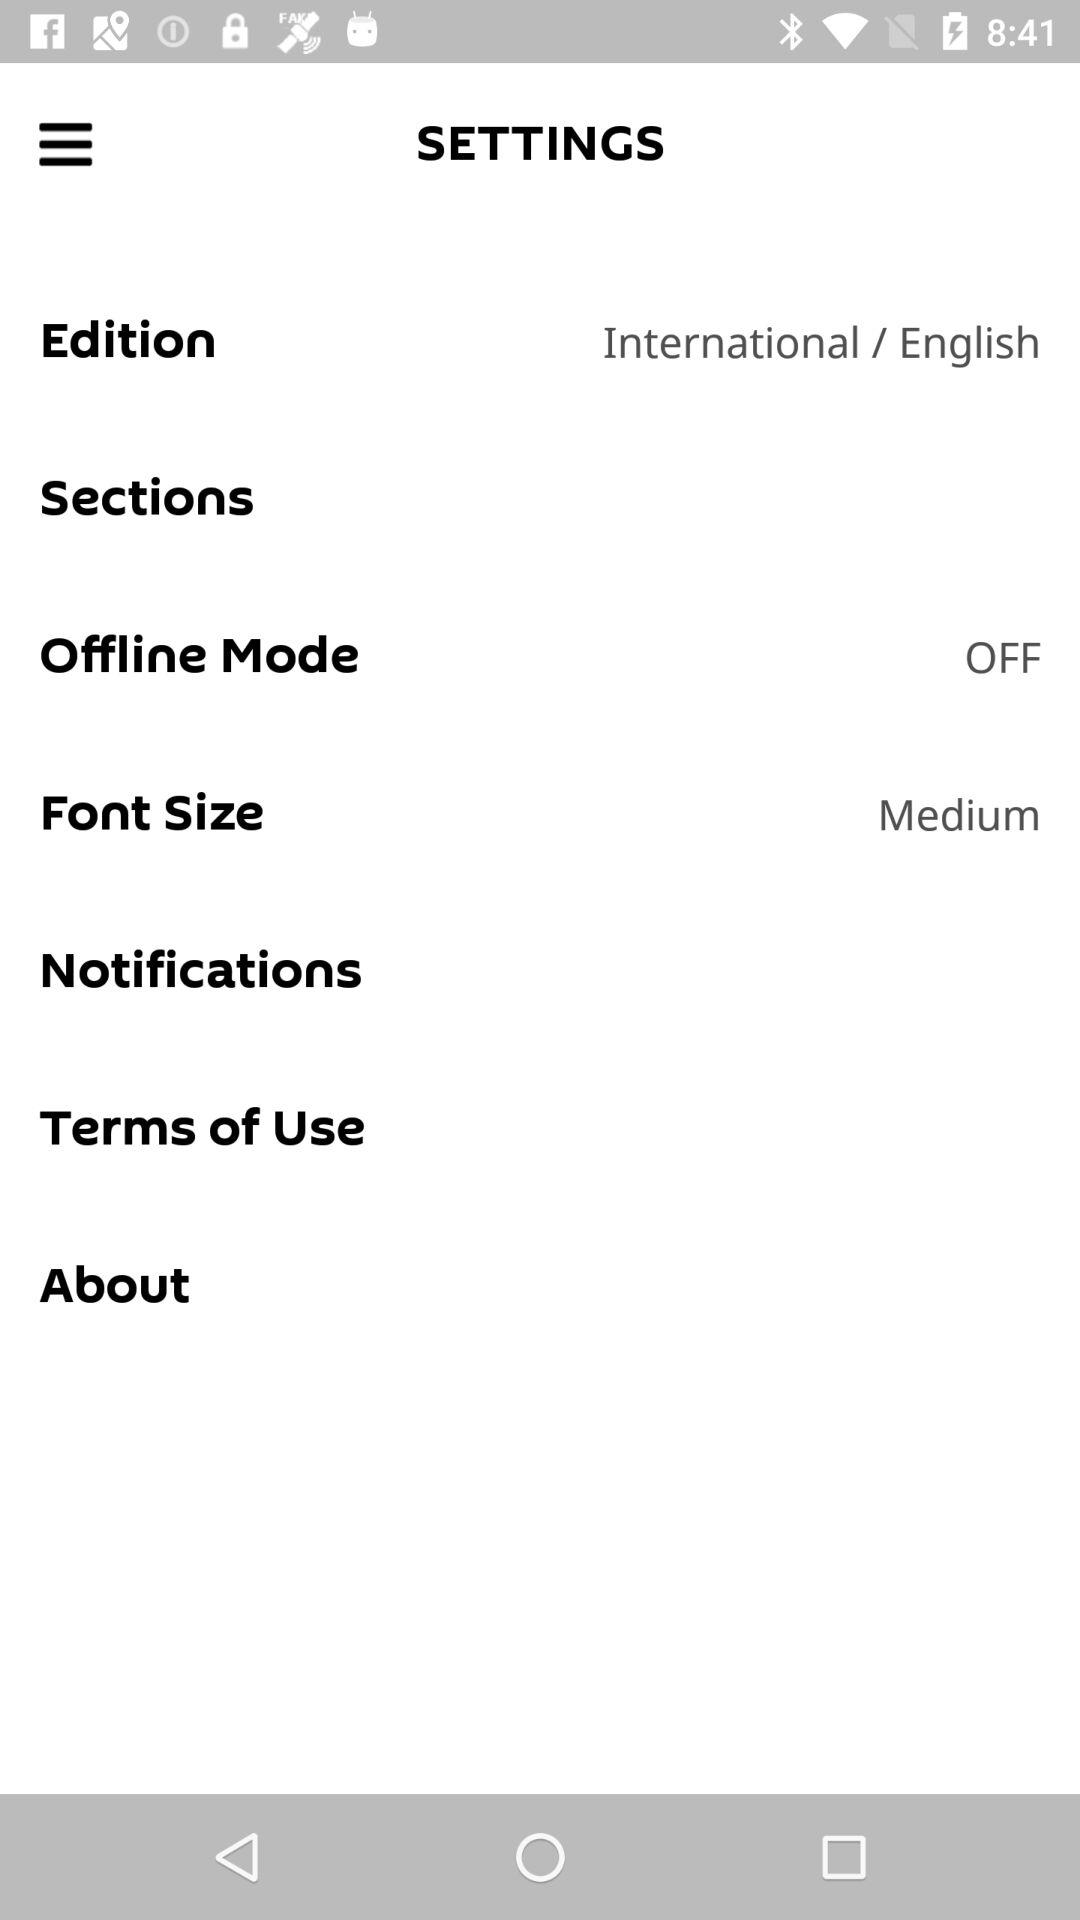What is the selected language for the edition? The selected language is English. 